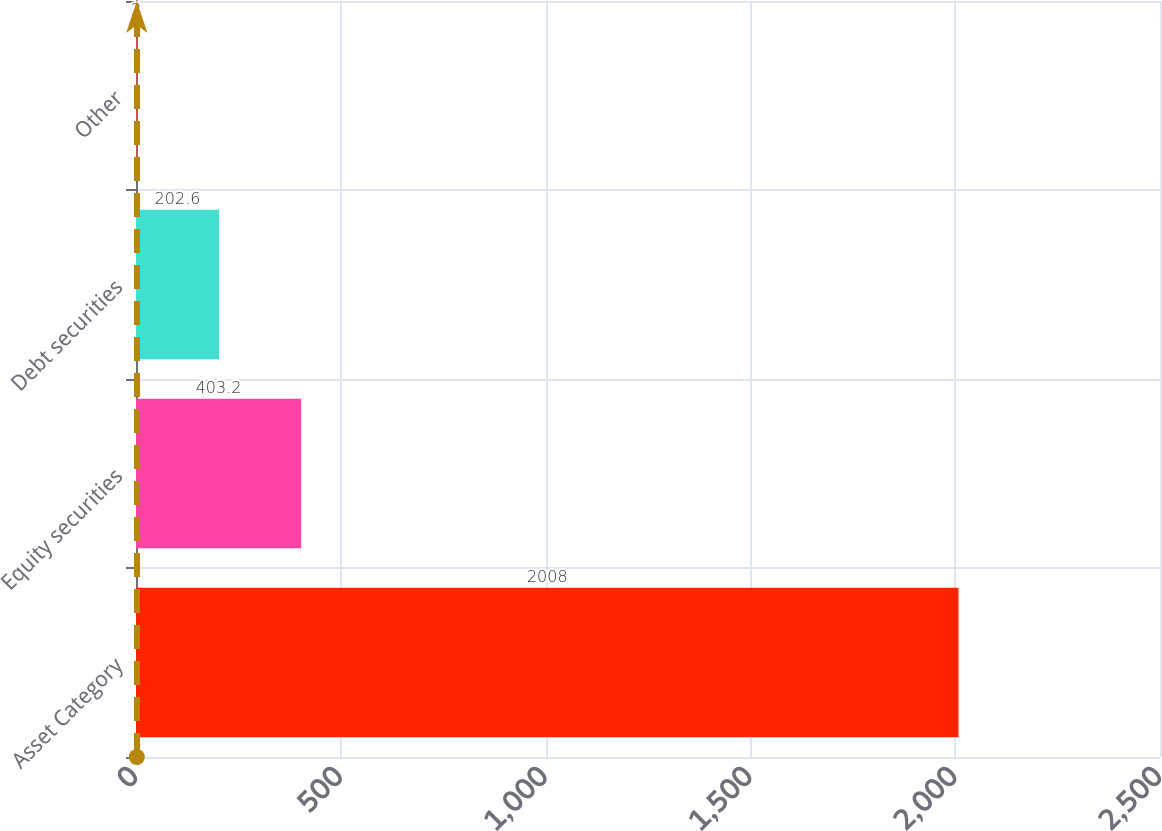Convert chart. <chart><loc_0><loc_0><loc_500><loc_500><bar_chart><fcel>Asset Category<fcel>Equity securities<fcel>Debt securities<fcel>Other<nl><fcel>2008<fcel>403.2<fcel>202.6<fcel>2<nl></chart> 